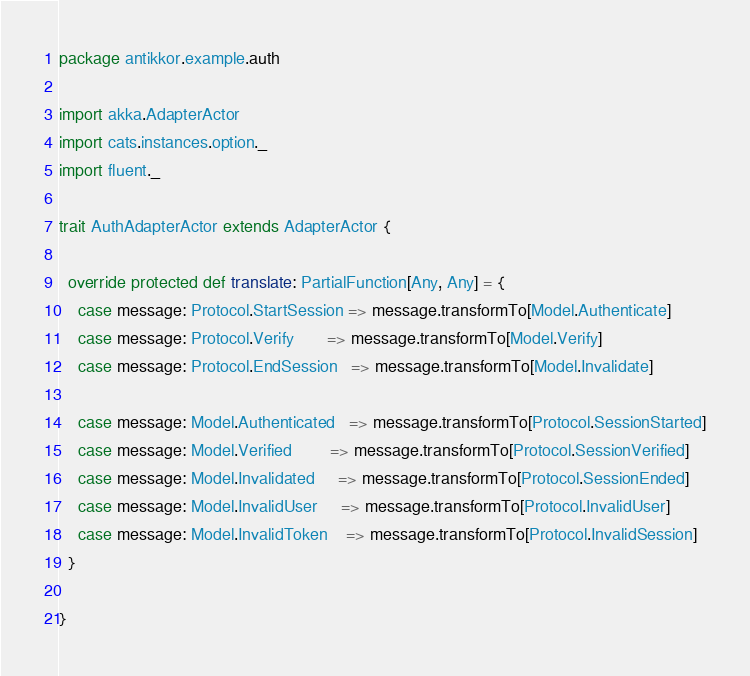<code> <loc_0><loc_0><loc_500><loc_500><_Scala_>package antikkor.example.auth

import akka.AdapterActor
import cats.instances.option._
import fluent._

trait AuthAdapterActor extends AdapterActor {

  override protected def translate: PartialFunction[Any, Any] = {
    case message: Protocol.StartSession => message.transformTo[Model.Authenticate]
    case message: Protocol.Verify       => message.transformTo[Model.Verify]
    case message: Protocol.EndSession   => message.transformTo[Model.Invalidate]

    case message: Model.Authenticated   => message.transformTo[Protocol.SessionStarted]
    case message: Model.Verified        => message.transformTo[Protocol.SessionVerified]
    case message: Model.Invalidated     => message.transformTo[Protocol.SessionEnded]
    case message: Model.InvalidUser     => message.transformTo[Protocol.InvalidUser]
    case message: Model.InvalidToken    => message.transformTo[Protocol.InvalidSession]
  }

}
</code> 